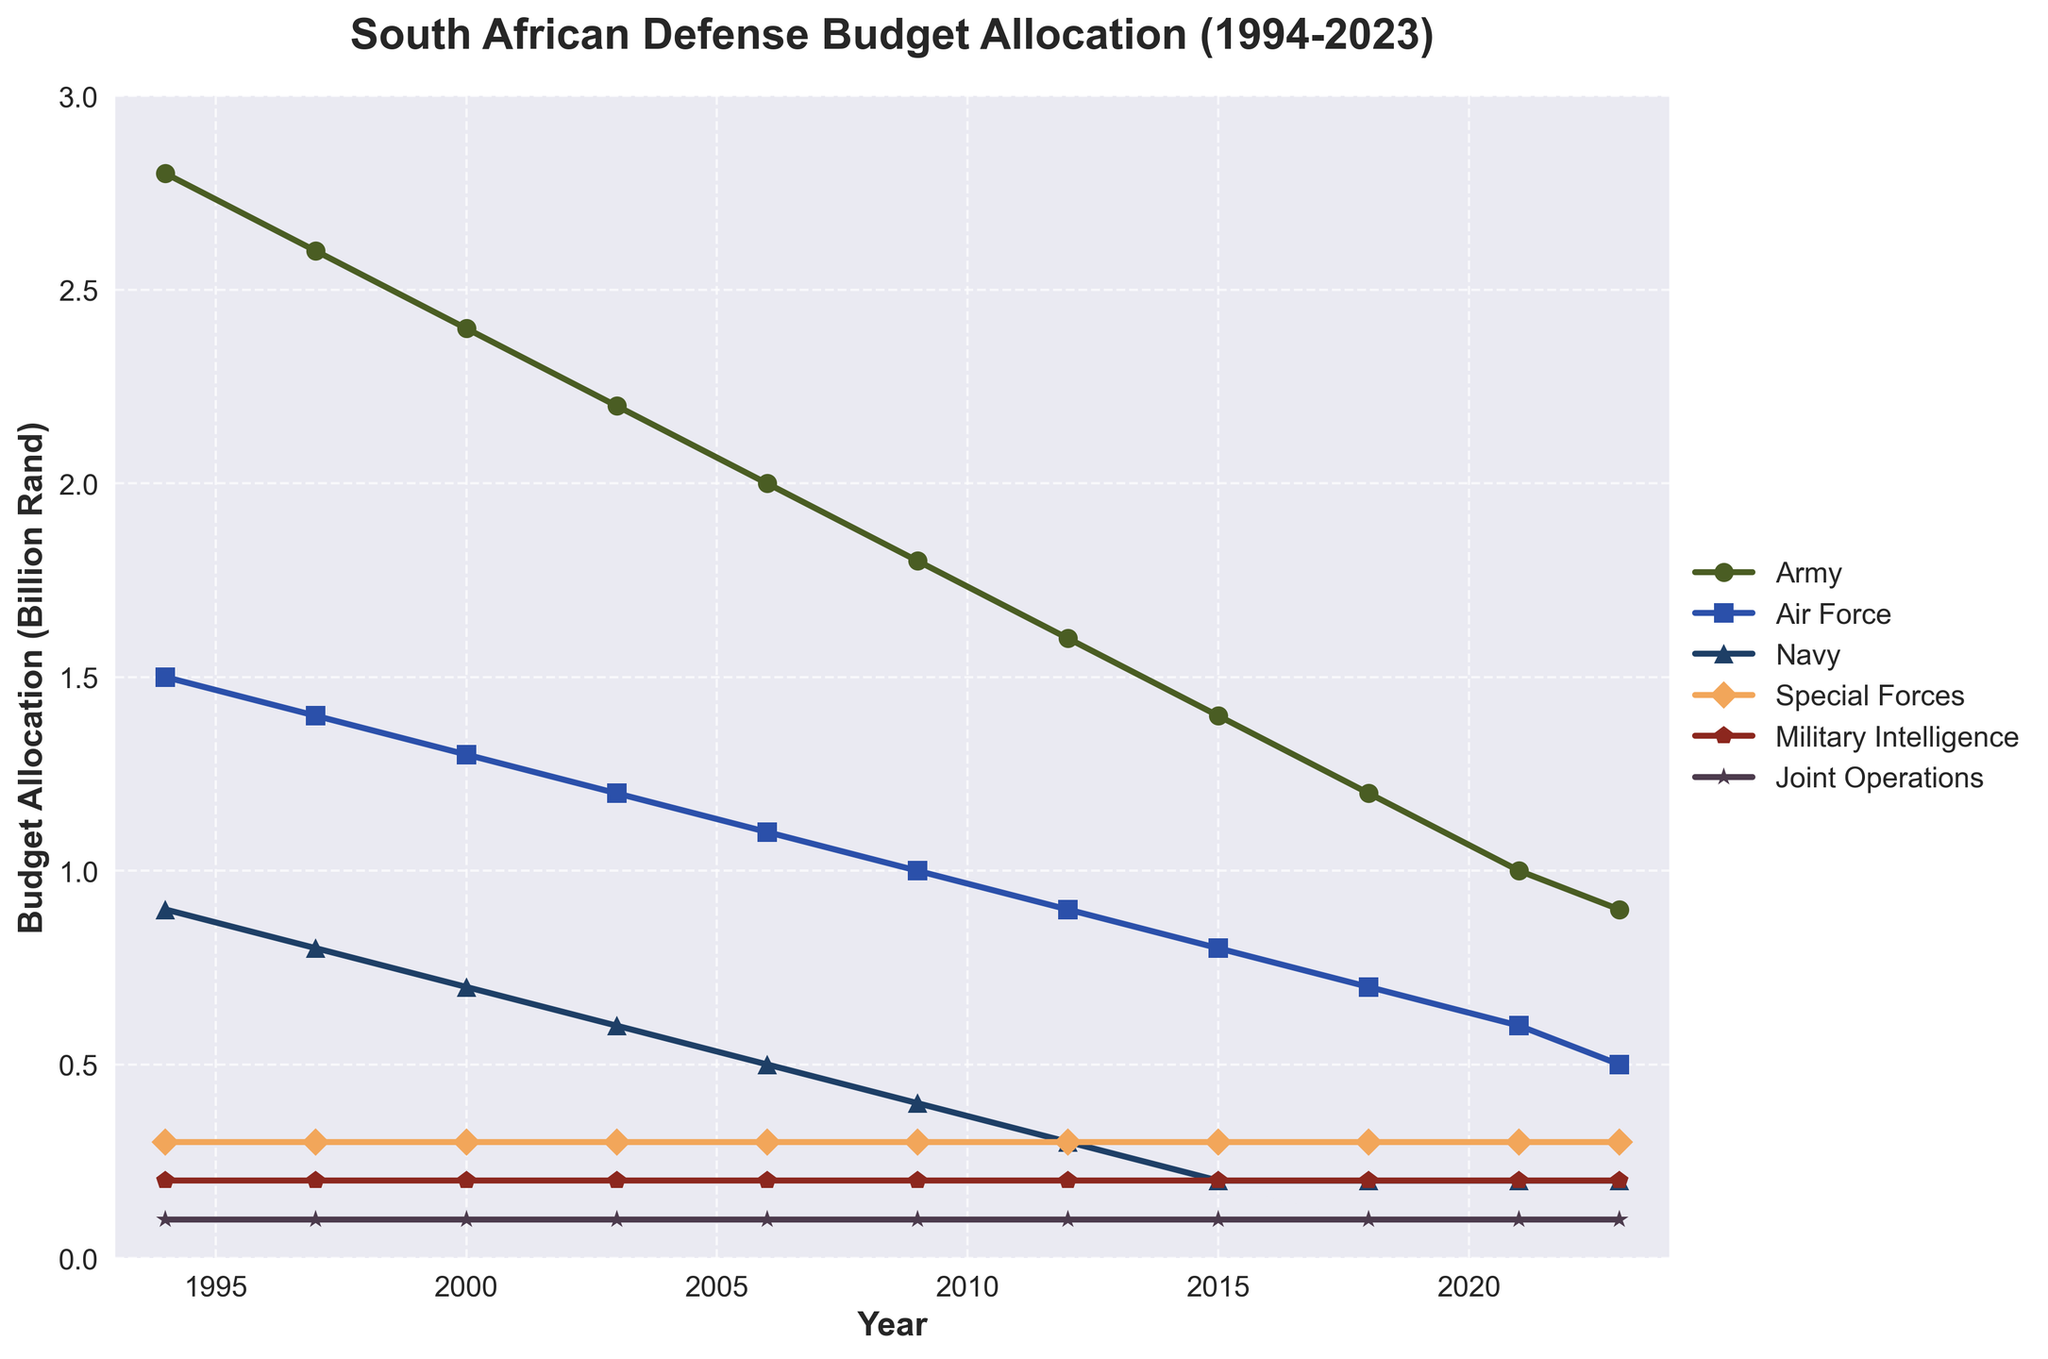What is the total budget allocation for the Army, Air Force, and Navy in 2023? To find the total budget allocation for the Army, Air Force, and Navy in 2023, sum the values for these branches: 0.9 (Army) + 0.5 (Air Force) + 0.2 (Navy).
Answer: 1.6 Which military branch had the least budget allocation in 2023? To determine the military branch with the least budget allocation in 2023, compare the values of all branches for that year. Special Forces, Military Intelligence, and Joint Operations each received 0.2 or 0.1 billion Rand, with Joint Operations being the lowest.
Answer: Joint Operations Did the budget allocation for the Army decrease steadily from 1994 to 2023? Examine the trend of the Army's budget allocation from 1994 to 2023. Note each year's value and see if it consistently decreases: 2.8 (1994), 2.6 (1997), 2.4 (2000), 2.2 (2003), 2.0 (2006), 1.8 (2009), 1.6 (2012), 1.4 (2015), 1.2 (2018), 1.0 (2021), 0.9 (2023). The trend is a steady decrease.
Answer: Yes In which year did the Army and Air Force budgets have the smallest difference? Calculate the difference between the Army and Air Force budgets for each year: (1994: 1.3, 1997: 1.2, 2000: 1.1, 2003: 1.0, 2006: 0.9, 2009: 0.8, 2012: 0.7, 2015: 0.6, 2018: 0.5, 2021: 0.4, 2023: 0.4). The smallest differences are 0.4 billion Rand in 2021 and 2023.
Answer: 2021 and 2023 What was the trend in budget allocation for Military Intelligence from 1994 to 2023? Look at the values for Military Intelligence from 1994 to 2023: 0.2 (1994-2023). The values remain constant throughout this period, indicating no increase or decrease.
Answer: No change Which branch had the most consistent budget allocation over the years, and what was the value? Identify the branch for which the budget allocation remained the same across the years by checking each value for all branches: Military Intelligence's budget allocation was consistently 0.2 billion Rand from 1994 to 2023.
Answer: Military Intelligence What is the average budget allocation for the Air Force from 1994 to 2023? Calculate the average by summing the Air Force's allocations for each year and dividing by the number of years: (1.5 + 1.4 + 1.3 + 1.2 + 1.1 + 1.0 + 0.9 + 0.8 + 0.7 + 0.6 + 0.5) / 11 = 10.0/11 ≈ 0.91.
Answer: 0.91 billion Rand How did the budget allocation for Special Forces change from 1994 to 2023? Compare the values for Special Forces in 1994 and 2023: 0.3 (1994) and 0.3 (2023). There was no change in the budget allocation for Special Forces during this period.
Answer: No change What is the combined budget allocation for all branches in the year 2000? Sum the budget allocations for all branches in 2000: 2.4 (Army) + 1.3 (Air Force) + 0.7 (Navy) + 0.3 (Special Forces) + 0.2 (Military Intelligence) + 0.1 (Joint Operations) = 5.0 billion Rand.
Answer: 5.0 billion Rand 